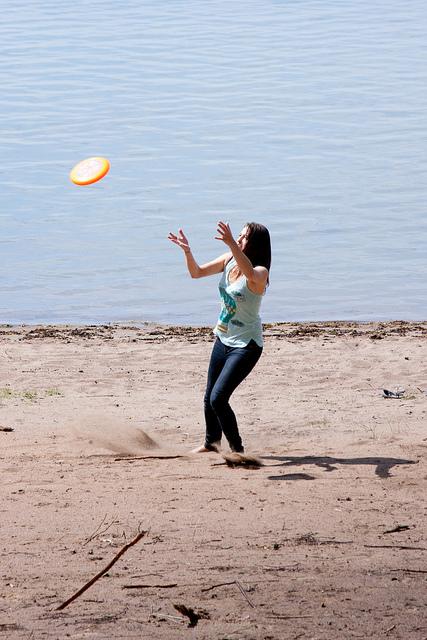Could the lady be barefooted?
Give a very brief answer. Yes. What is the child reaching for?
Keep it brief. Frisbee. What is in the sand at the edge of the water?
Short answer required. Rocks. What color frisbee is this?
Concise answer only. Orange. Are both feet on the sand?
Answer briefly. Yes. 